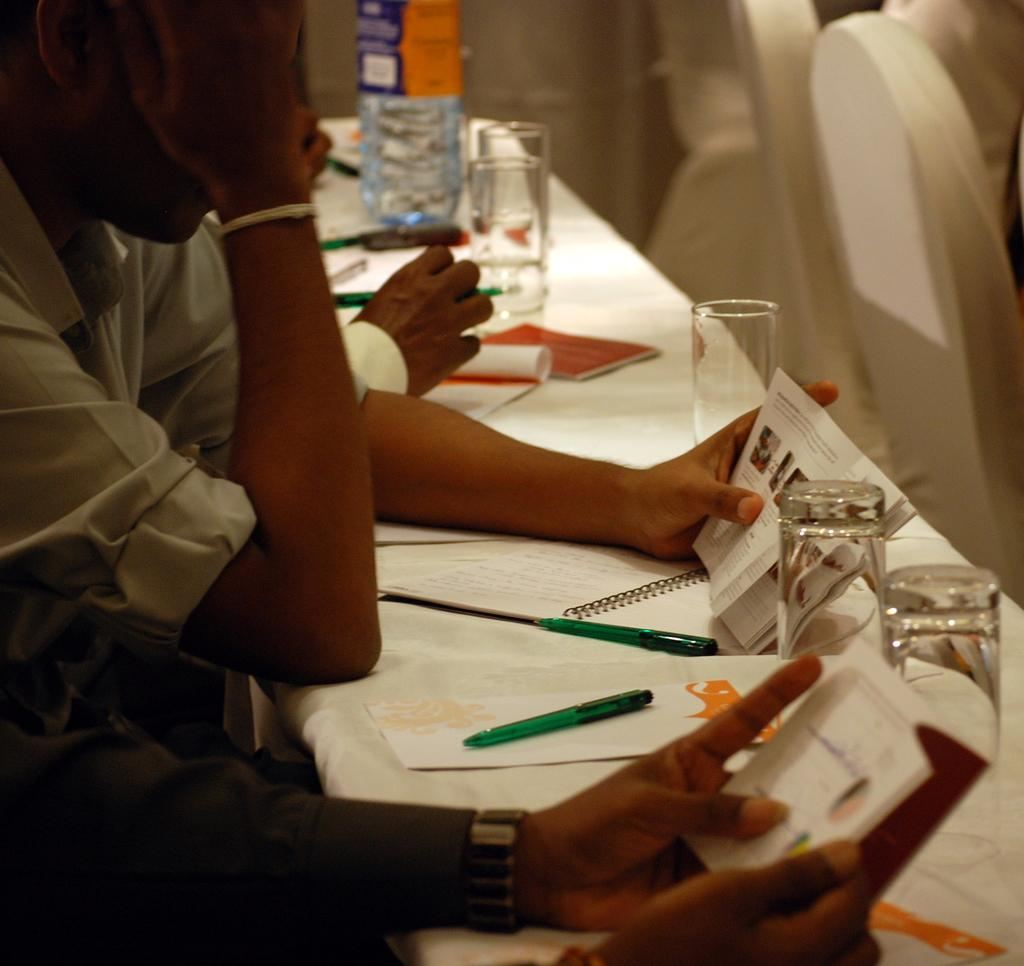What are the persons in the image doing? The persons in the image are sitting. What is the color of the desks in the image? The desks are white colored. What items can be seen on the desks? There are papers, pens, glasses, and other objects on the desks. What type of roof can be seen in the image? There is no roof visible in the image; it appears to be an indoor setting. What kind of control is being exercised by the persons in the image? There is no indication of control being exercised by the persons in the image; they are simply sitting at desks. 